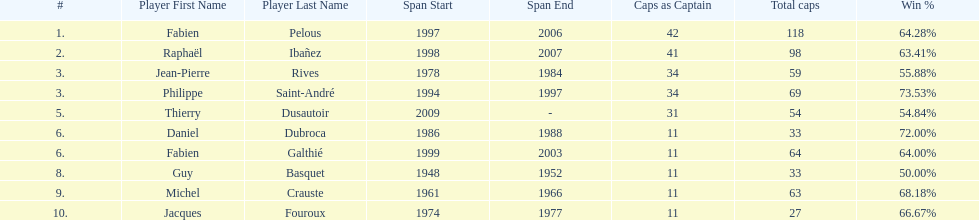How long did michel crauste serve as captain? 1961-1966. 